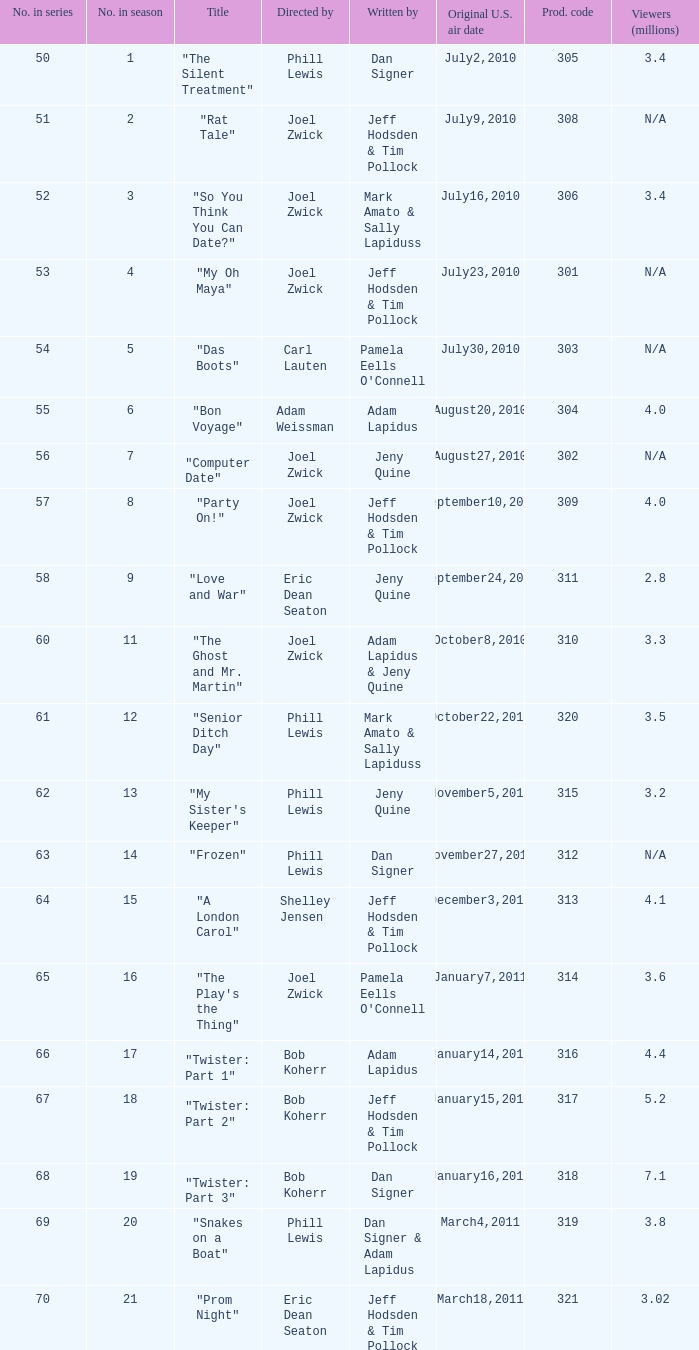Which US air date had 4.4 million viewers? January14,2011. 